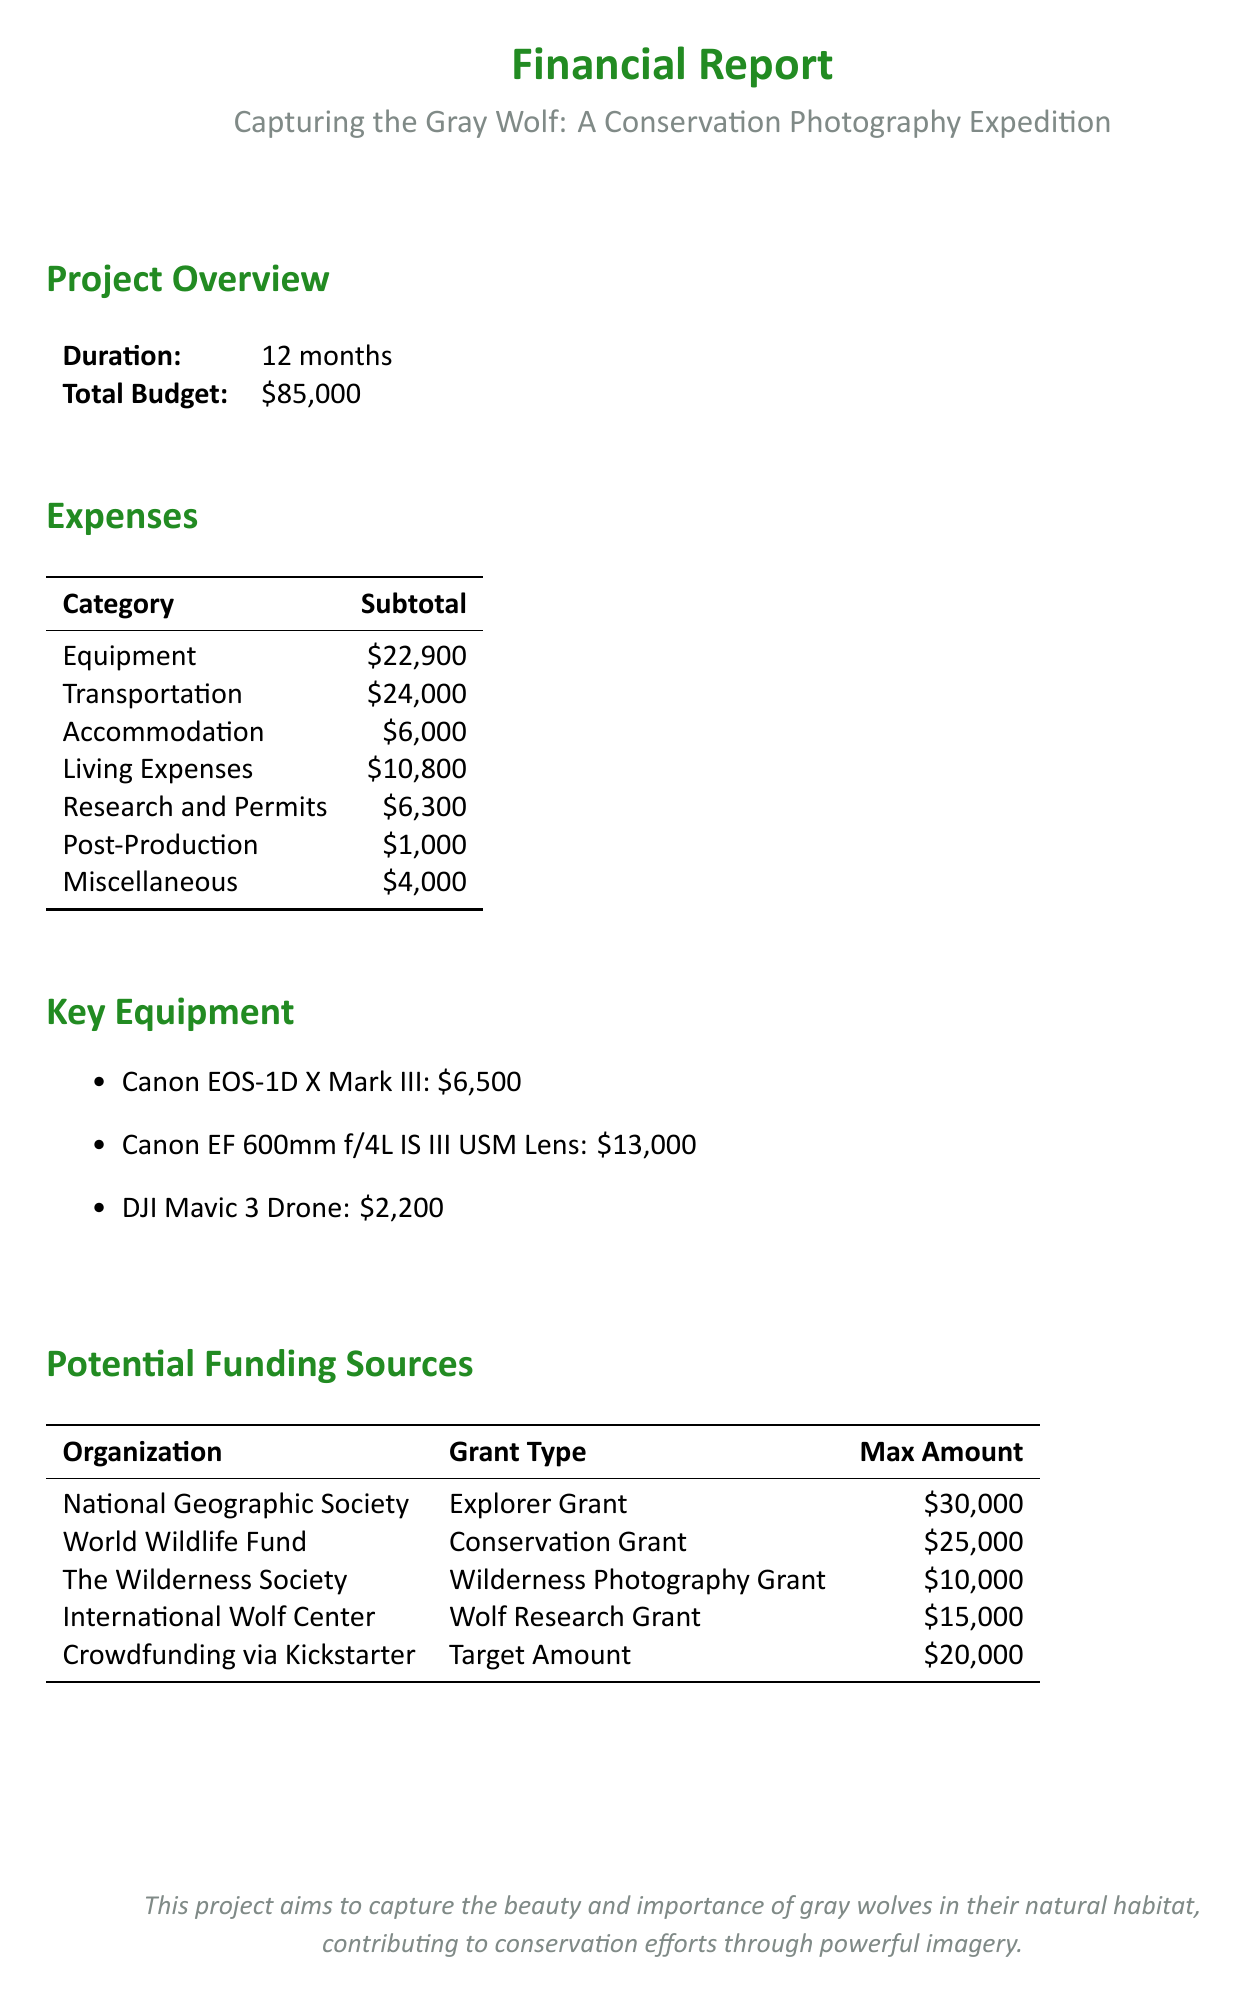what is the project title? The project title is explicitly stated at the beginning of the document.
Answer: Capturing the Gray Wolf: A Conservation Photography Expedition what is the total budget for the project? The total budget is mentioned in the project overview section.
Answer: $85,000 how much is allocated for transportation expenses? Transportation expenses are detailed in the expenses section of the document.
Answer: $24,000 which item has the highest expense in the equipment category? The equipment category lists individual items with their costs, allowing identification of the highest expense.
Answer: Canon EF 600mm f/4L IS III USM Lens how much can be received from the World Wildlife Fund? The grant type and maximum amount for the World Wildlife Fund is provided in the potential funding sources section.
Answer: $25,000 what is the duration of the project? The project duration is clearly stated in the project overview section.
Answer: 12 months calculate the subtotal of accommodation expenses. Accommodation expenses are listed in the expenses section, providing a subtotal that can be easily retrieved.
Answer: $6,000 which grant type does the National Geographic Society offer? The grant type for the National Geographic Society is specified in the potential funding sources section of the document.
Answer: Explorer Grant how much is budgeted for post-production expenses? The post-production expenses are included in the overall expenses breakdown, allowing one to find the specific amount allocated.
Answer: $1,000 